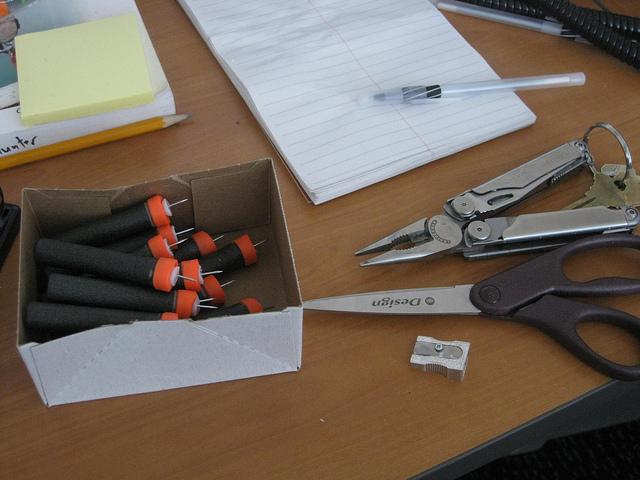What color are the scissor handles?
Answer briefly. Black. What object is propping up the pen?
Short answer required. Paper. How many writing utensils are in the photo?
Quick response, please. 2. Is there a phone in this picture?
Give a very brief answer. No. What color is the handle of the scissors?
Answer briefly. Black. What color are the needle-nosed pliers?
Give a very brief answer. Silver. What is in this picture?
Answer briefly. Scissors. What is on the paper?
Quick response, please. Pen. Are there any scissors on top of the paper?
Write a very short answer. No. 